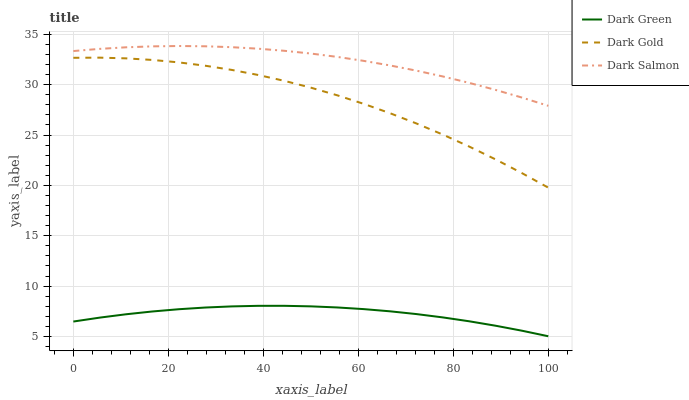Does Dark Green have the minimum area under the curve?
Answer yes or no. Yes. Does Dark Salmon have the maximum area under the curve?
Answer yes or no. Yes. Does Dark Salmon have the minimum area under the curve?
Answer yes or no. No. Does Dark Green have the maximum area under the curve?
Answer yes or no. No. Is Dark Green the smoothest?
Answer yes or no. Yes. Is Dark Gold the roughest?
Answer yes or no. Yes. Is Dark Salmon the smoothest?
Answer yes or no. No. Is Dark Salmon the roughest?
Answer yes or no. No. Does Dark Green have the lowest value?
Answer yes or no. Yes. Does Dark Salmon have the lowest value?
Answer yes or no. No. Does Dark Salmon have the highest value?
Answer yes or no. Yes. Does Dark Green have the highest value?
Answer yes or no. No. Is Dark Gold less than Dark Salmon?
Answer yes or no. Yes. Is Dark Salmon greater than Dark Gold?
Answer yes or no. Yes. Does Dark Gold intersect Dark Salmon?
Answer yes or no. No. 